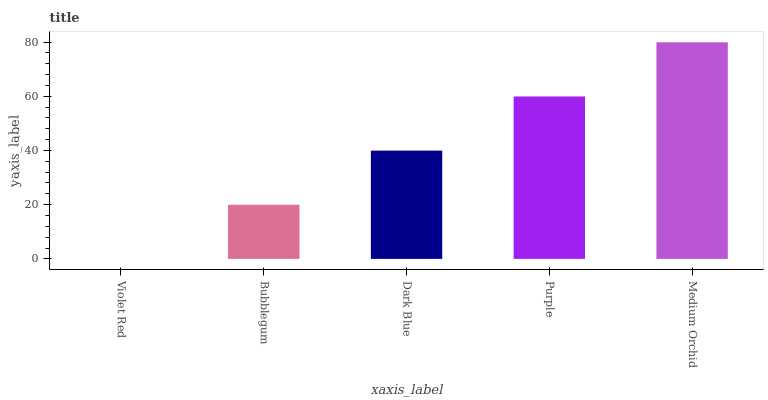Is Bubblegum the minimum?
Answer yes or no. No. Is Bubblegum the maximum?
Answer yes or no. No. Is Bubblegum greater than Violet Red?
Answer yes or no. Yes. Is Violet Red less than Bubblegum?
Answer yes or no. Yes. Is Violet Red greater than Bubblegum?
Answer yes or no. No. Is Bubblegum less than Violet Red?
Answer yes or no. No. Is Dark Blue the high median?
Answer yes or no. Yes. Is Dark Blue the low median?
Answer yes or no. Yes. Is Violet Red the high median?
Answer yes or no. No. Is Bubblegum the low median?
Answer yes or no. No. 